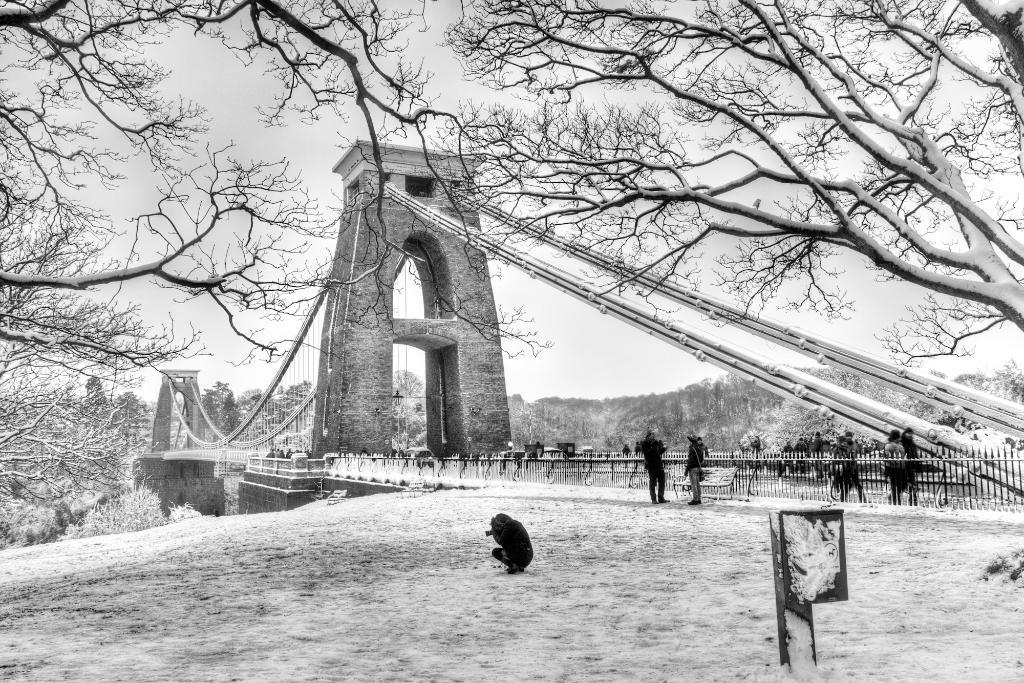What is the color scheme of the image? The image is black and white. What is located in the middle of the image? There is a bridge and trees in the middle of the image. What is visible at the top of the image? The sky is visible at the top of the image. What can be seen in the middle of the image besides the bridge and trees? There are persons standing in the middle of the image. What type of lettuce can be seen growing on the bridge in the image? There is no lettuce present in the image, and the bridge does not have any plants growing on it. How many stamps are visible on the persons standing in the middle of the image? There are no stamps visible on the persons standing in the middle of the image. 